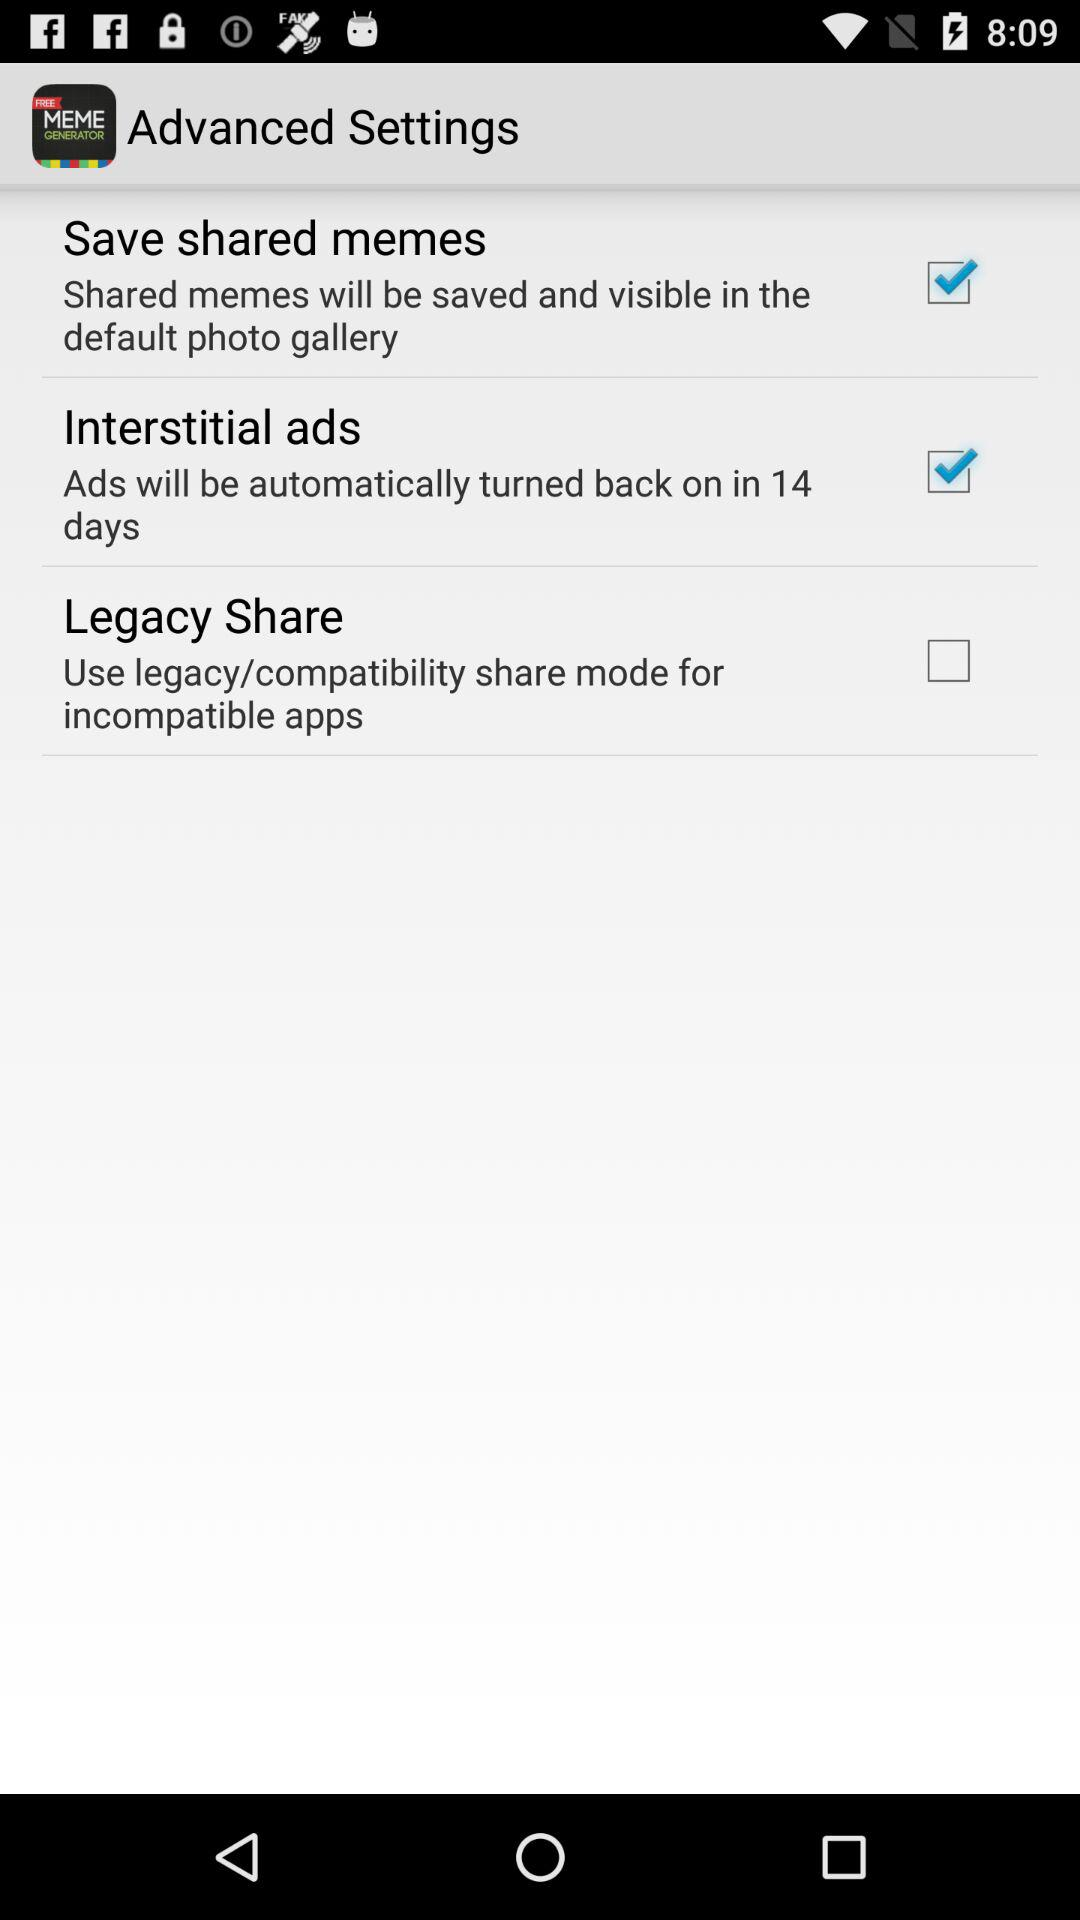Which options are checked in "Advance Settings"? The options are "Save shared memes" and "Interstitial ads". 